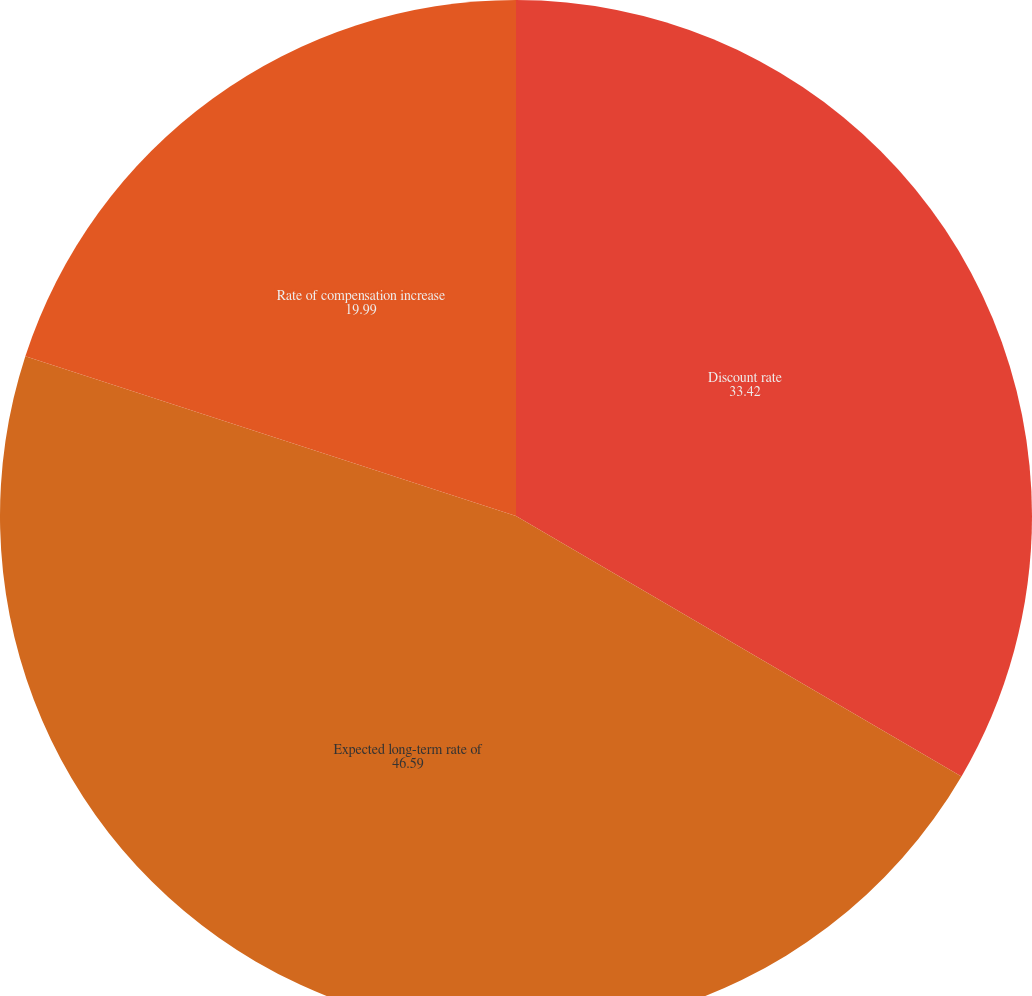Convert chart. <chart><loc_0><loc_0><loc_500><loc_500><pie_chart><fcel>Discount rate<fcel>Expected long-term rate of<fcel>Rate of compensation increase<nl><fcel>33.42%<fcel>46.59%<fcel>19.99%<nl></chart> 